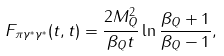Convert formula to latex. <formula><loc_0><loc_0><loc_500><loc_500>F _ { \pi \gamma ^ { * } \gamma ^ { * } } ( t , t ) = \frac { 2 M _ { Q } ^ { 2 } } { \beta _ { Q } t } \ln \frac { \beta _ { Q } + 1 } { \beta _ { Q } - 1 } ,</formula> 